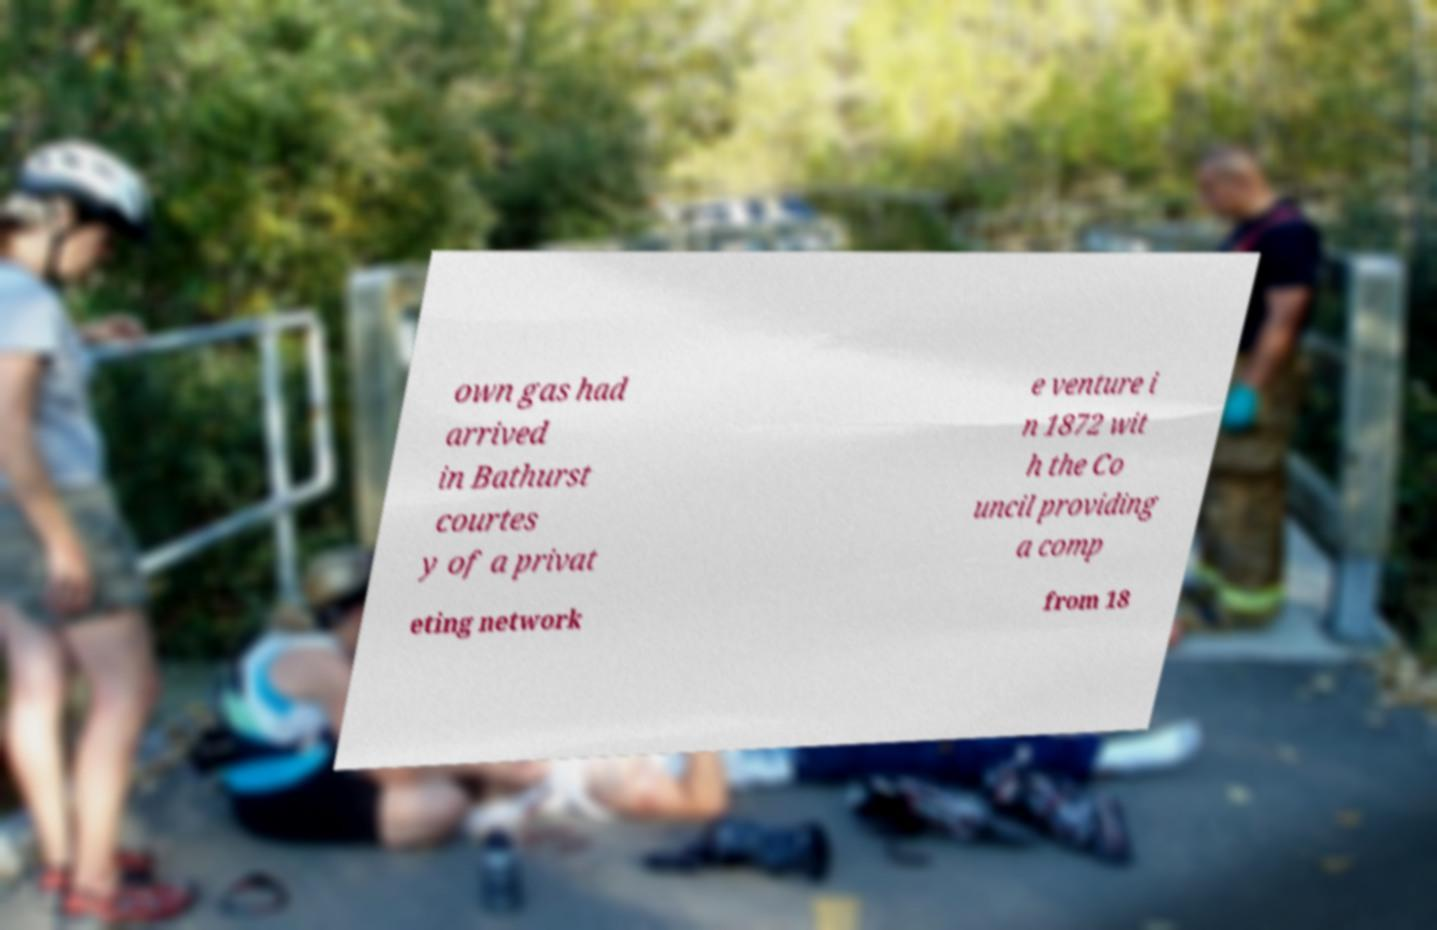What messages or text are displayed in this image? I need them in a readable, typed format. own gas had arrived in Bathurst courtes y of a privat e venture i n 1872 wit h the Co uncil providing a comp eting network from 18 